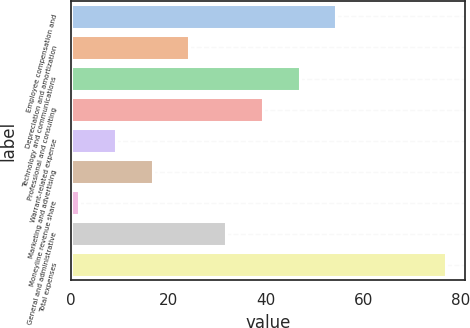Convert chart to OTSL. <chart><loc_0><loc_0><loc_500><loc_500><bar_chart><fcel>Employee compensation and<fcel>Depreciation and amortization<fcel>Technology and communications<fcel>Professional and consulting<fcel>Warrant-related expense<fcel>Marketing and advertising<fcel>Moneyline revenue share<fcel>General and administrative<fcel>Total expenses<nl><fcel>54.45<fcel>24.25<fcel>46.9<fcel>39.35<fcel>9.15<fcel>16.7<fcel>1.6<fcel>31.8<fcel>77.1<nl></chart> 